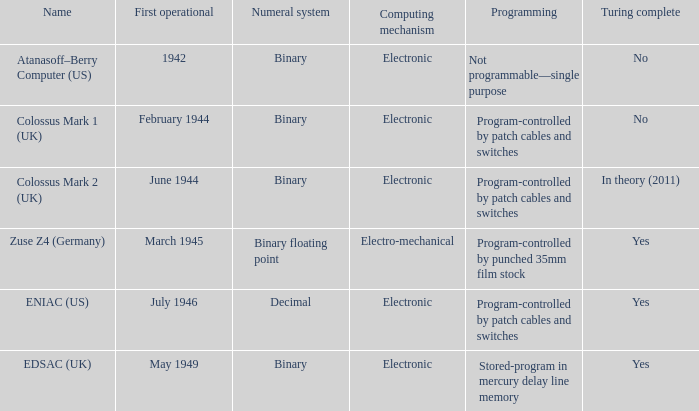What's the first operational with programming being not programmable—single purpose 1942.0. 